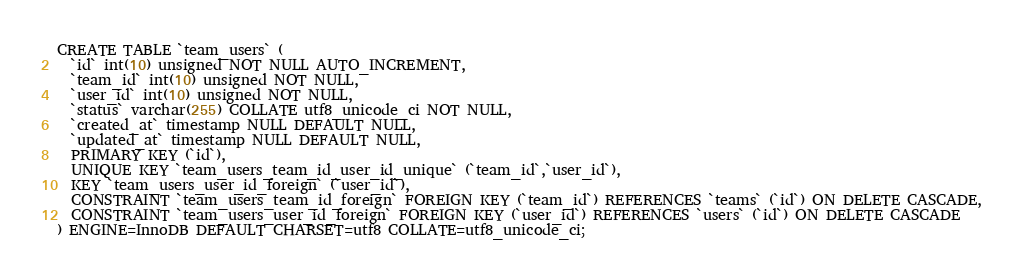Convert code to text. <code><loc_0><loc_0><loc_500><loc_500><_SQL_>CREATE TABLE `team_users` (
  `id` int(10) unsigned NOT NULL AUTO_INCREMENT,
  `team_id` int(10) unsigned NOT NULL,
  `user_id` int(10) unsigned NOT NULL,
  `status` varchar(255) COLLATE utf8_unicode_ci NOT NULL,
  `created_at` timestamp NULL DEFAULT NULL,
  `updated_at` timestamp NULL DEFAULT NULL,
  PRIMARY KEY (`id`),
  UNIQUE KEY `team_users_team_id_user_id_unique` (`team_id`,`user_id`),
  KEY `team_users_user_id_foreign` (`user_id`),
  CONSTRAINT `team_users_team_id_foreign` FOREIGN KEY (`team_id`) REFERENCES `teams` (`id`) ON DELETE CASCADE,
  CONSTRAINT `team_users_user_id_foreign` FOREIGN KEY (`user_id`) REFERENCES `users` (`id`) ON DELETE CASCADE
) ENGINE=InnoDB DEFAULT CHARSET=utf8 COLLATE=utf8_unicode_ci;</code> 